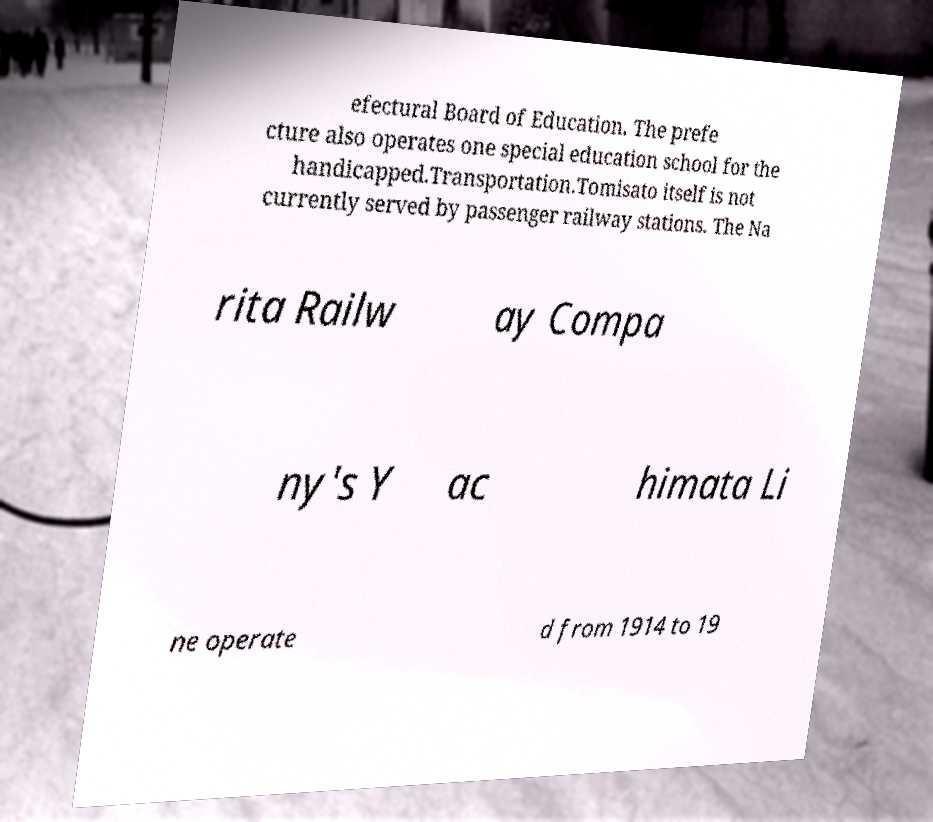Can you accurately transcribe the text from the provided image for me? efectural Board of Education. The prefe cture also operates one special education school for the handicapped.Transportation.Tomisato itself is not currently served by passenger railway stations. The Na rita Railw ay Compa ny's Y ac himata Li ne operate d from 1914 to 19 